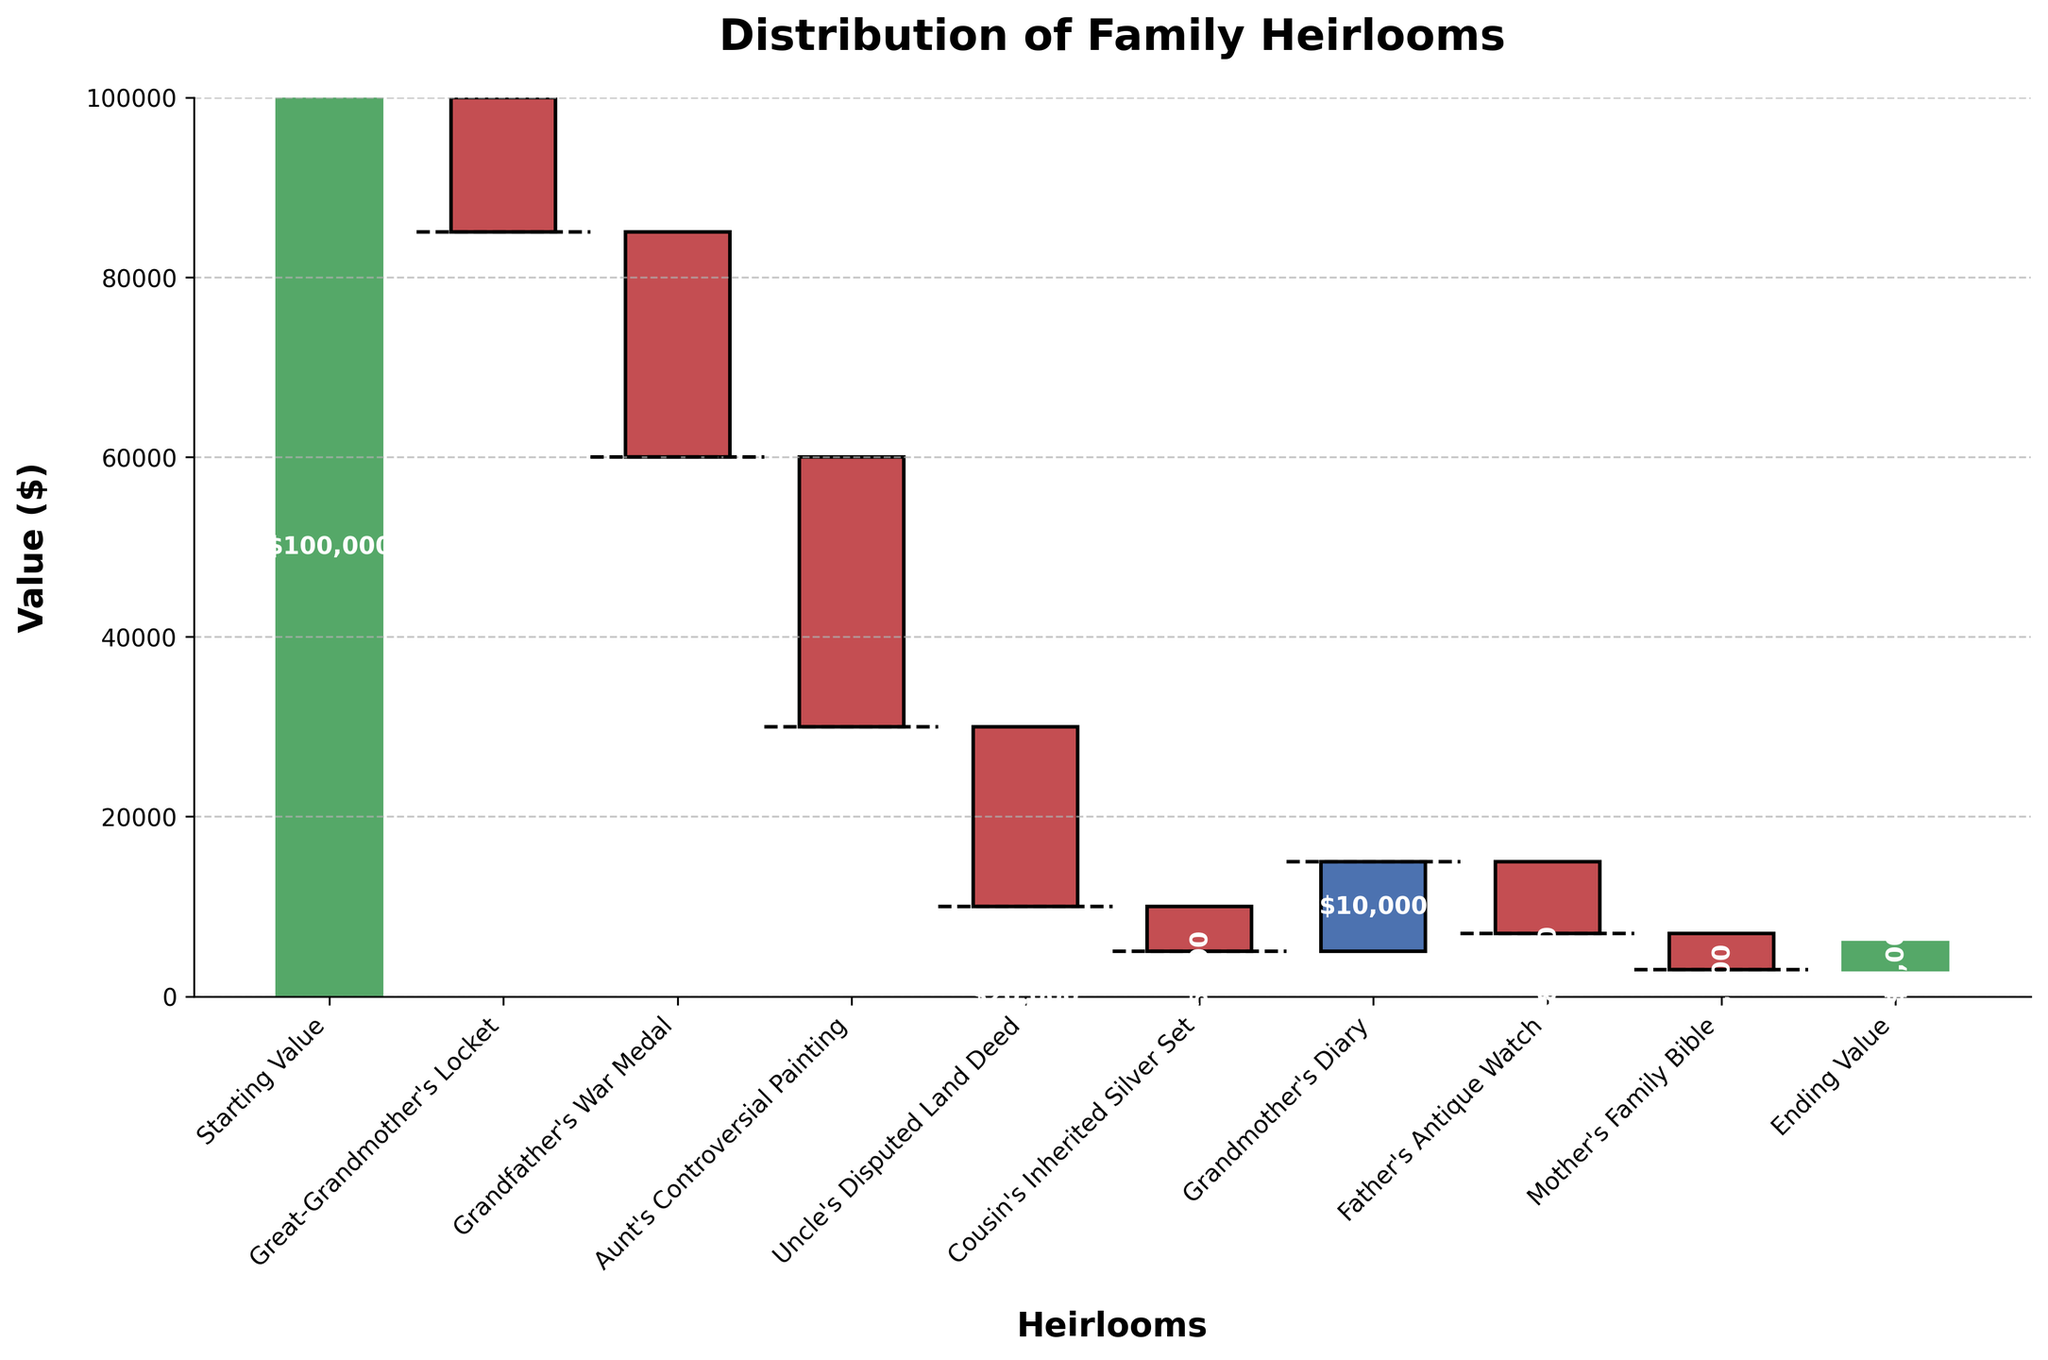What is the title of the chart? The title is displayed at the top of the chart and provides a high-level summary of the data presented. The title reads "Distribution of Family Heirlooms."
Answer: Distribution of Family Heirlooms What is the total value represented by the ending value? The total value represented by the ending value is indicated by the last bar in the chart, which reads "Ending Value." The value is shown at the bottom of the stack.
Answer: $3,000 Which heirloom caused the largest decrease in total value? To identify the heirloom causing the largest decrease, look for the bar with the largest drop from its baseline. The "Aunt's Controversial Painting" shows the largest negative value of -$30,000.
Answer: Aunt's Controversial Painting How much was the value of the Great-Grandmother's Locket? The value associated with the Great-Grandmother's Locket can be directly read from its label on the chart. The value shown is -$15,000.
Answer: $-15,000 What is the cumulative value after the Grandfather's War Medal? To find the cumulative value after the Grandfather's War Medal, add the values from the Starting Value and subtract the value of the Great-Grandmother's Locket and Grandfather's War Medal: $100,000 - $15,000 - $25,000 = $60,000.
Answer: $60,000 Which item has the smallest negative impact on the total value? By comparing the negative values, the "Cousin's Inherited Silver Set" has the smallest negative impact with a value of -$5,000.
Answer: Cousin's Inherited Silver Set What is the combined decrease in value contributed by all controversial heirlooms? To find the combined decrease, sum the values of items with negative amounts: Great-Grandmother's Locket (-$15,000), Grandfather's War Medal (-$25,000), Aunt's Controversial Painting (-$30,000), Uncle's Disputed Land Deed (-$20,000), Cousin's Inherited Silver Set (-$5,000), Father's Antique Watch (-$8,000), Mother's Family Bible (-$4,000). Total is -$15,000 - $25,000 - $30,000 - $20,000 - $5,000 - $8,000 - $4,000 = $-107,000.
Answer: $-107,000 How many heirlooms have a positive impact on total value? Identify the bars with positive values. There are two positive bars: "Grandmother's Diary" ($10,000) and "Ending Value" ($3,000).
Answer: 2 What is the cumulative value before and after the addition of Grandmother's Diary? Calculate the cumulative value just before and just after adding the Grandmother's Diary. The value before is: $100,000 - $95,000 - $25,000 - $30,000 - $20,000 - $5,000 = $5,000. After adding the Grandmother's Diary, it becomes $5,000 + $10,000 = $15,000.
Answer: $5,000 and $15,000 